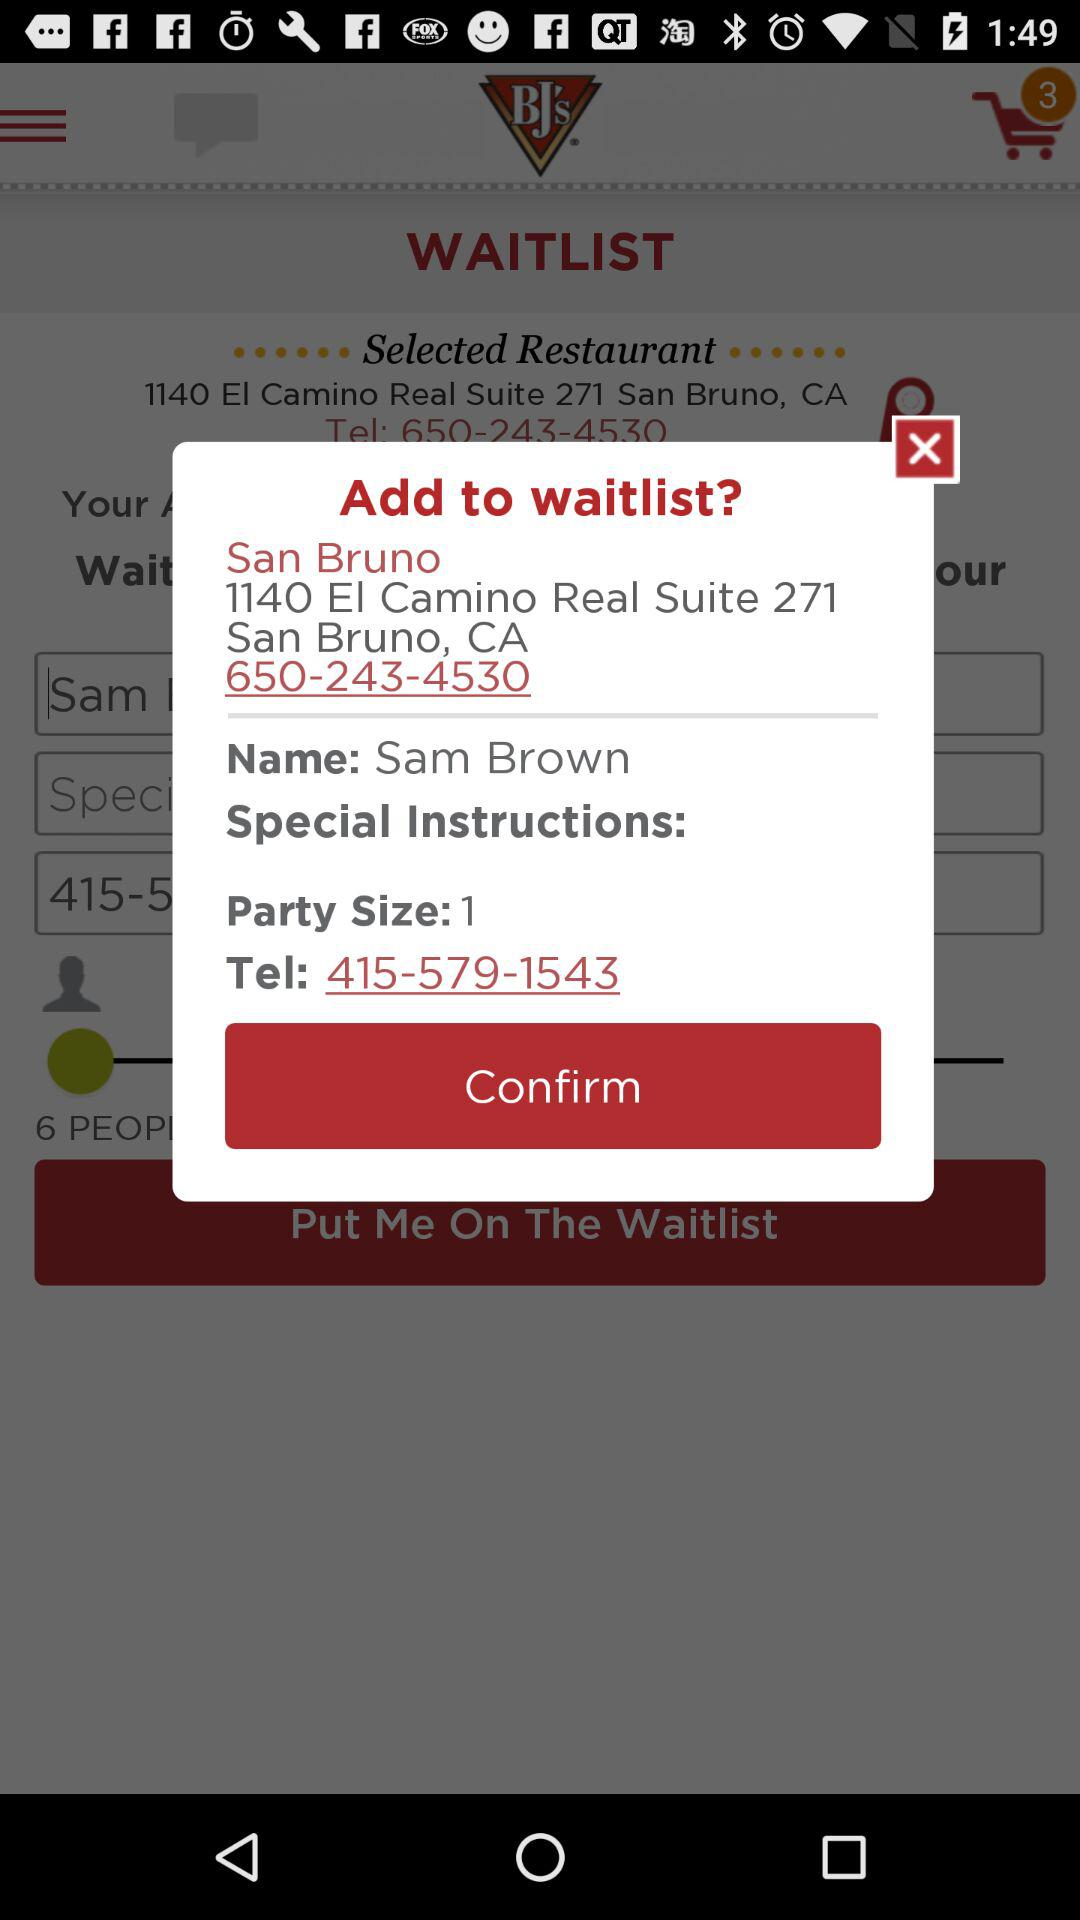What is the user name? The user name is Sam Brown. 